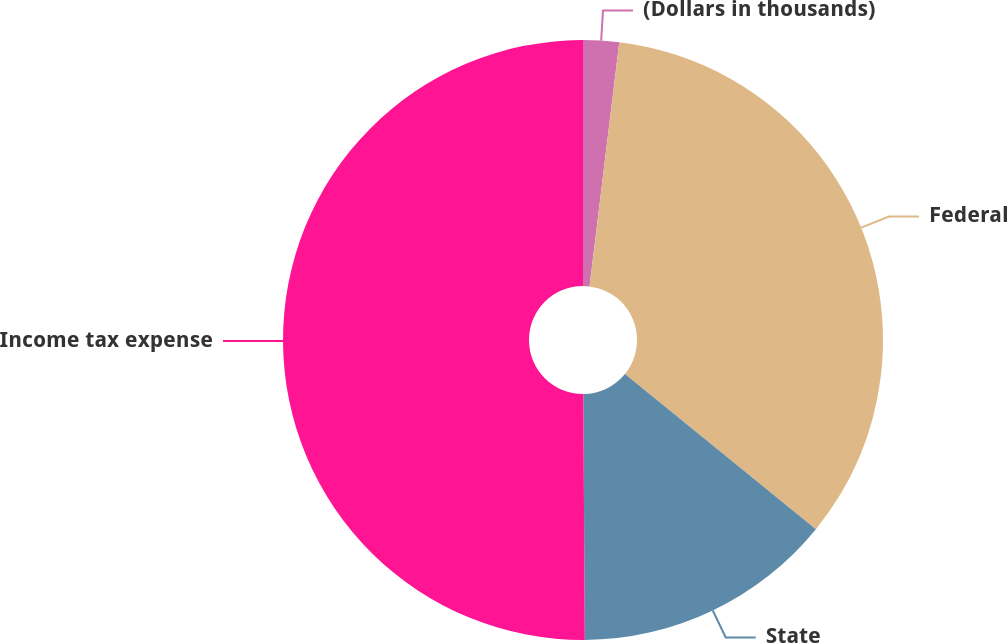Convert chart to OTSL. <chart><loc_0><loc_0><loc_500><loc_500><pie_chart><fcel>(Dollars in thousands)<fcel>Federal<fcel>State<fcel>Income tax expense<nl><fcel>1.93%<fcel>33.93%<fcel>14.05%<fcel>50.1%<nl></chart> 